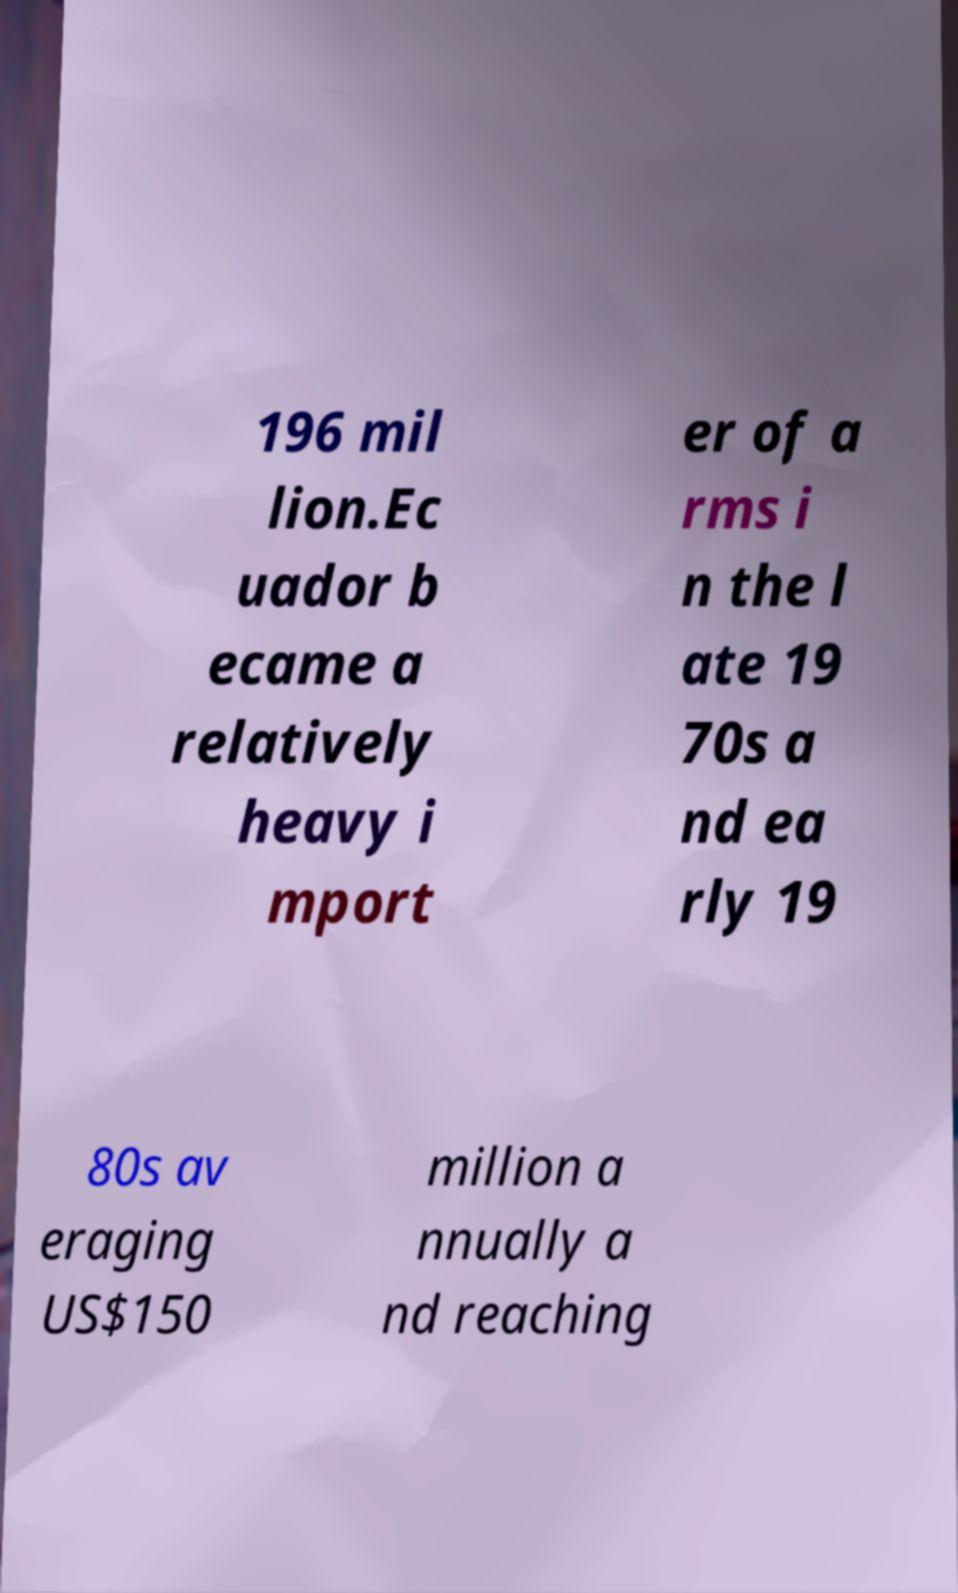Can you accurately transcribe the text from the provided image for me? 196 mil lion.Ec uador b ecame a relatively heavy i mport er of a rms i n the l ate 19 70s a nd ea rly 19 80s av eraging US$150 million a nnually a nd reaching 